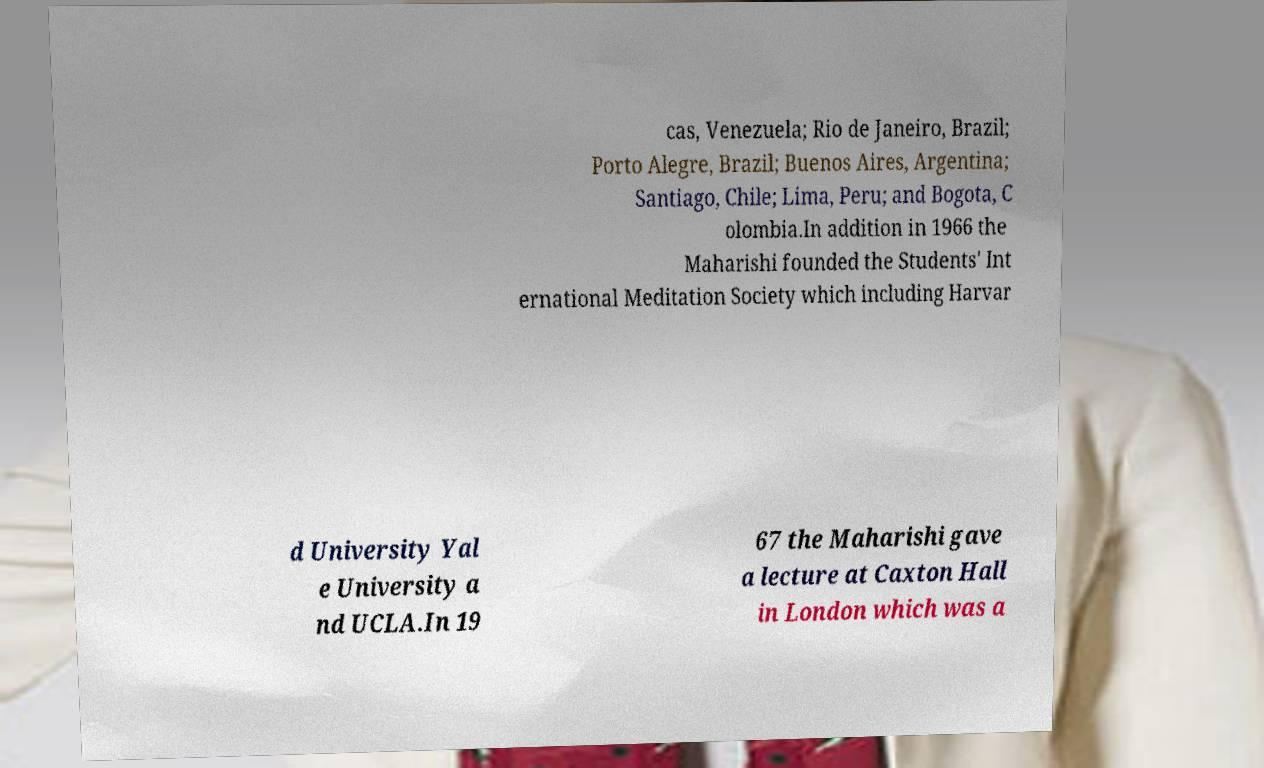Could you extract and type out the text from this image? cas, Venezuela; Rio de Janeiro, Brazil; Porto Alegre, Brazil; Buenos Aires, Argentina; Santiago, Chile; Lima, Peru; and Bogota, C olombia.In addition in 1966 the Maharishi founded the Students' Int ernational Meditation Society which including Harvar d University Yal e University a nd UCLA.In 19 67 the Maharishi gave a lecture at Caxton Hall in London which was a 